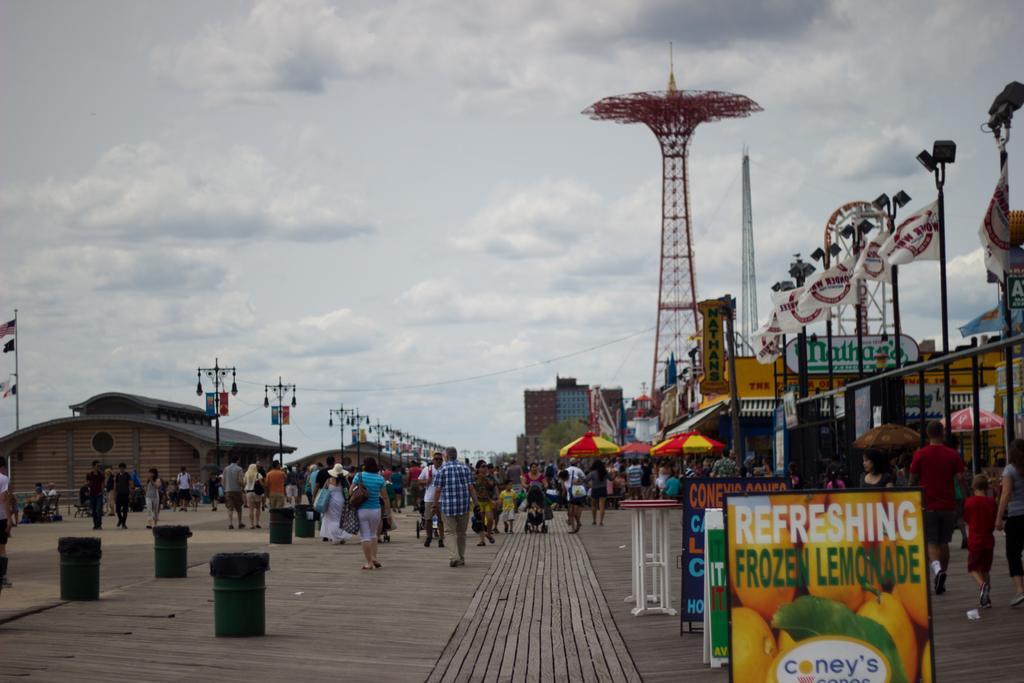Could you give a brief overview of what you see in this image? In this image there is the sky towards the top of the image, there are clouds in the sky, there are poles, there are street lights, there are buildings, there are flags, there are towers, there is ground towards the bottom of the image, there are dustbins on the ground, there are groups of persons walking, there are umbrellas, there are boards, there is text on the boards. 